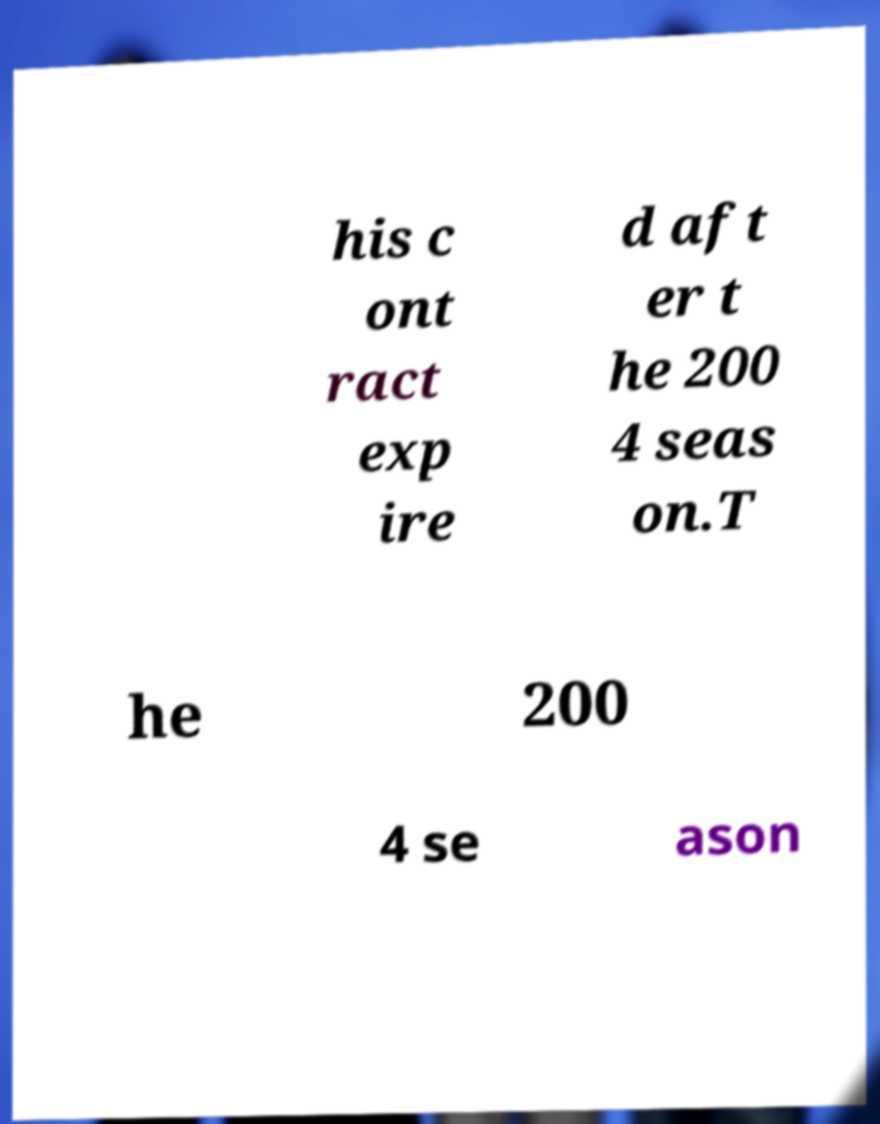Could you extract and type out the text from this image? his c ont ract exp ire d aft er t he 200 4 seas on.T he 200 4 se ason 